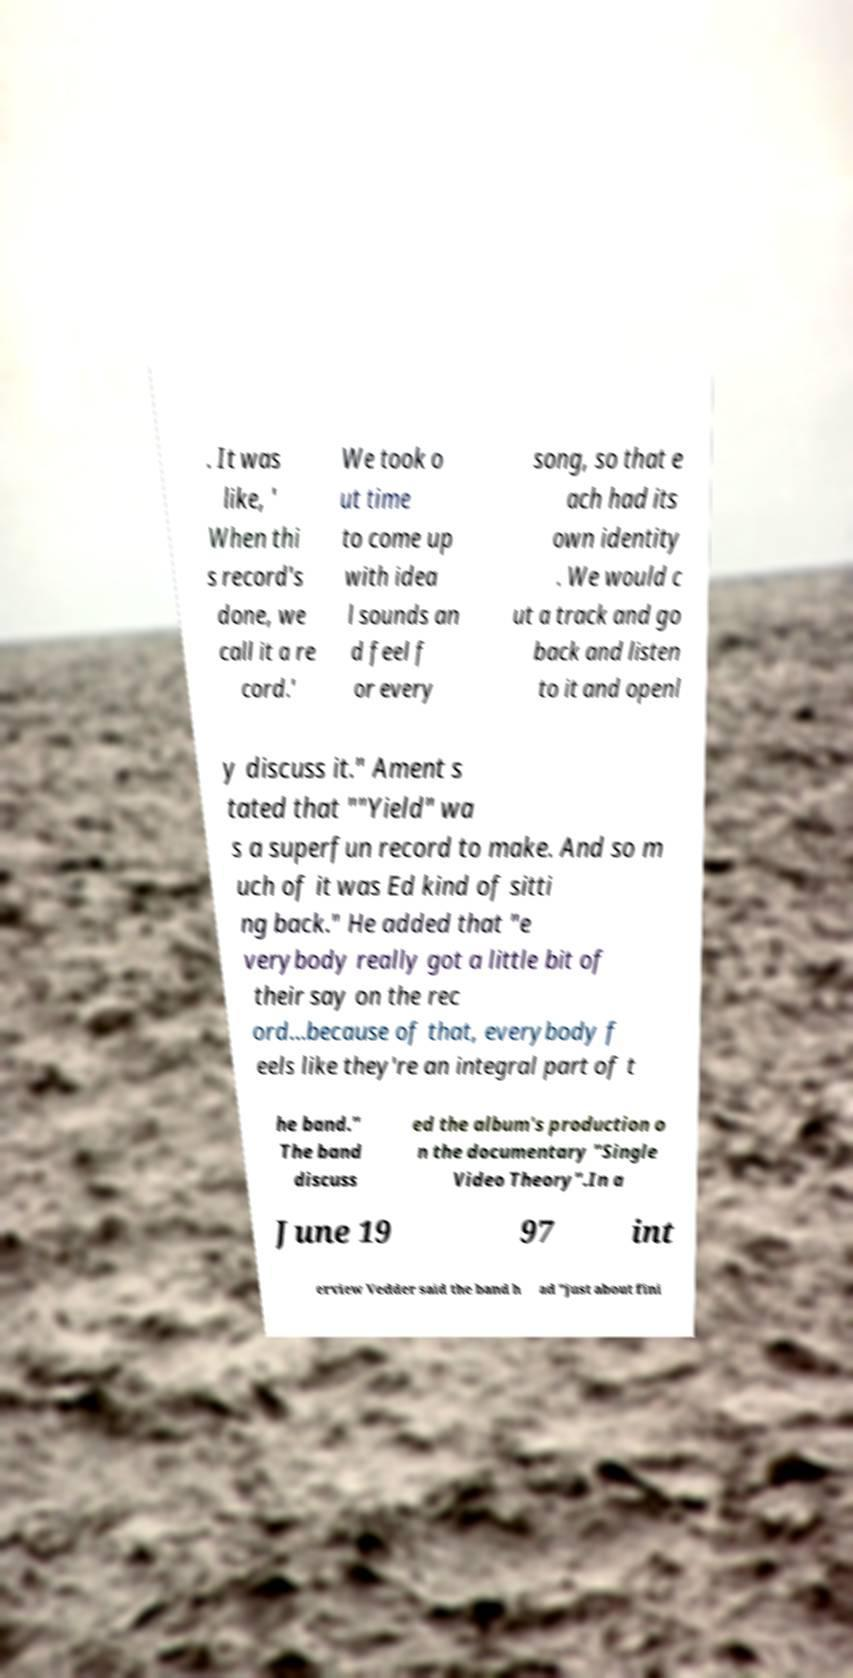Please identify and transcribe the text found in this image. . It was like, ' When thi s record's done, we call it a re cord.' We took o ut time to come up with idea l sounds an d feel f or every song, so that e ach had its own identity . We would c ut a track and go back and listen to it and openl y discuss it." Ament s tated that ""Yield" wa s a superfun record to make. And so m uch of it was Ed kind of sitti ng back." He added that "e verybody really got a little bit of their say on the rec ord...because of that, everybody f eels like they're an integral part of t he band." The band discuss ed the album's production o n the documentary "Single Video Theory".In a June 19 97 int erview Vedder said the band h ad "just about fini 